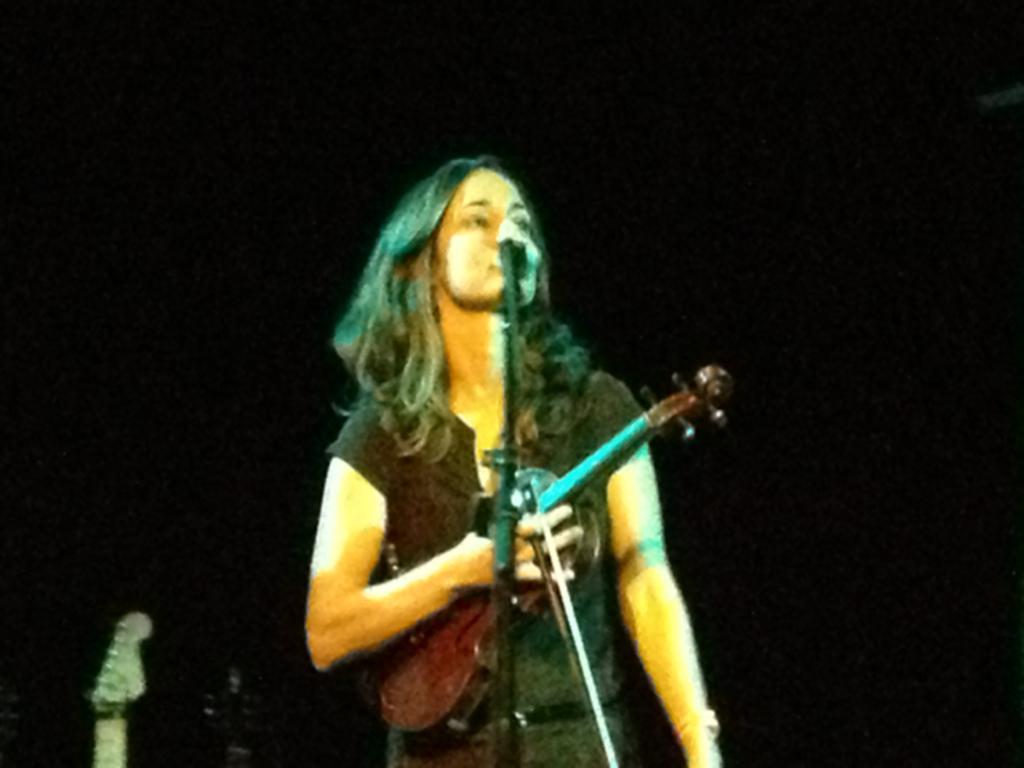In one or two sentences, can you explain what this image depicts? Blur image. This woman is holding violin and singing in-front of mic. 